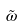<formula> <loc_0><loc_0><loc_500><loc_500>\tilde { \omega }</formula> 